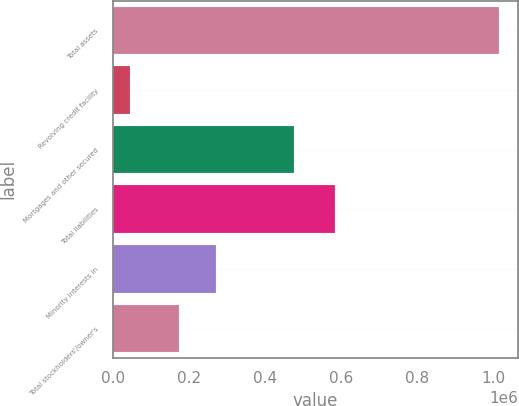<chart> <loc_0><loc_0><loc_500><loc_500><bar_chart><fcel>Total assets<fcel>Revolving credit facility<fcel>Mortgages and other secured<fcel>Total liabilities<fcel>Minority interests in<fcel>Total stockholders'/owner's<nl><fcel>1.01329e+06<fcel>44000<fcel>475498<fcel>584229<fcel>270128<fcel>173199<nl></chart> 